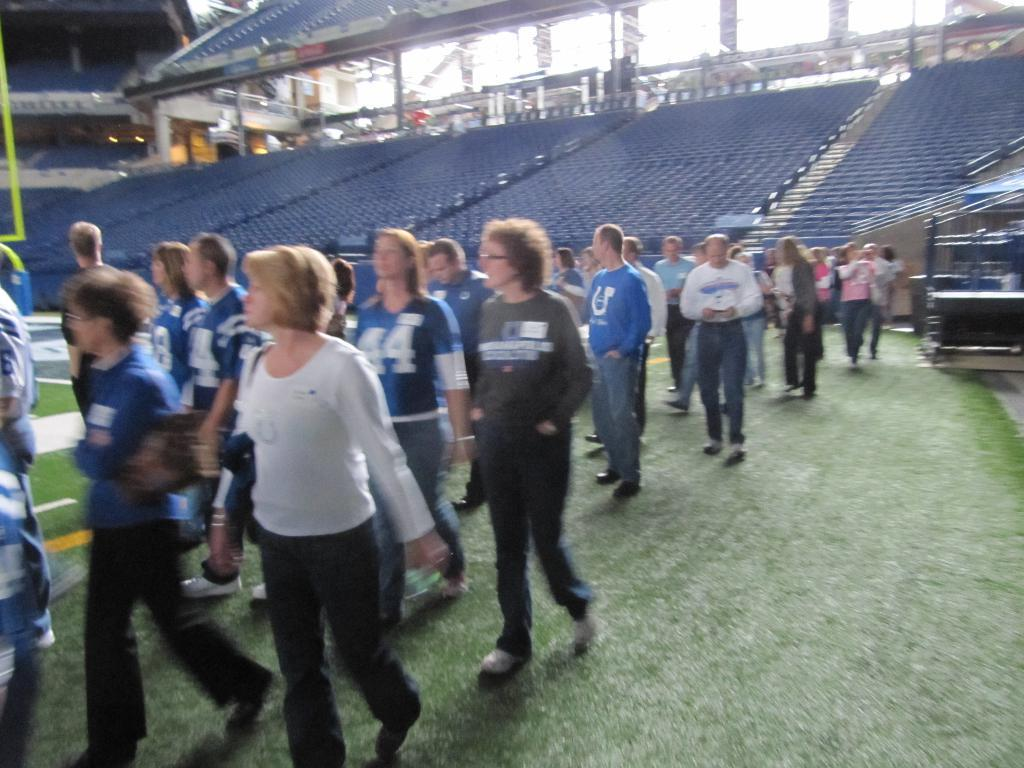What can be seen in the image? There are people standing in the image. What is located in the background of the image? There are bleachers in the background of the image. What type of structure is visible in the image? There is a roof visible in the image. What is on the right side of the image? There is a shed on the right side of the image. What type of ground surface is present at the bottom of the image? There is grass at the bottom of the image. What type of engine is visible in the image? There is no engine present in the image. What emotion can be seen on the faces of the people in the image? The provided facts do not mention the emotions of the people in the image, so we cannot determine their emotions from the information given. 